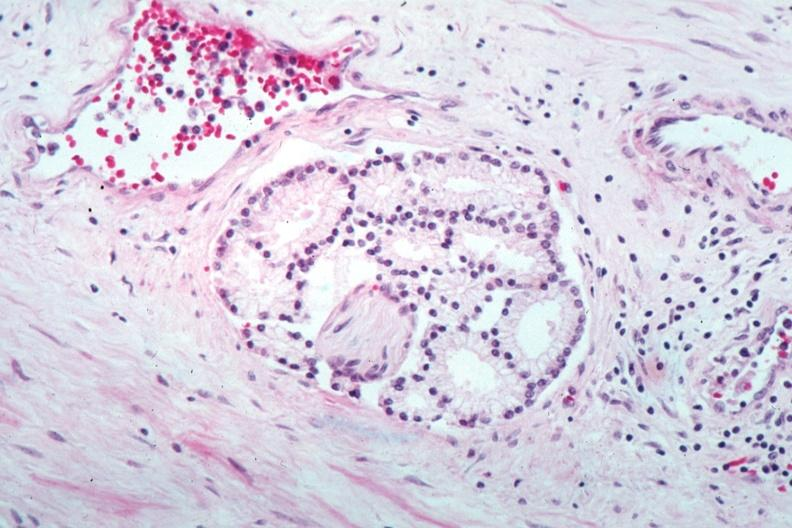does this image show perineural invasion by a well differentiated adenocarcinoma?
Answer the question using a single word or phrase. Yes 